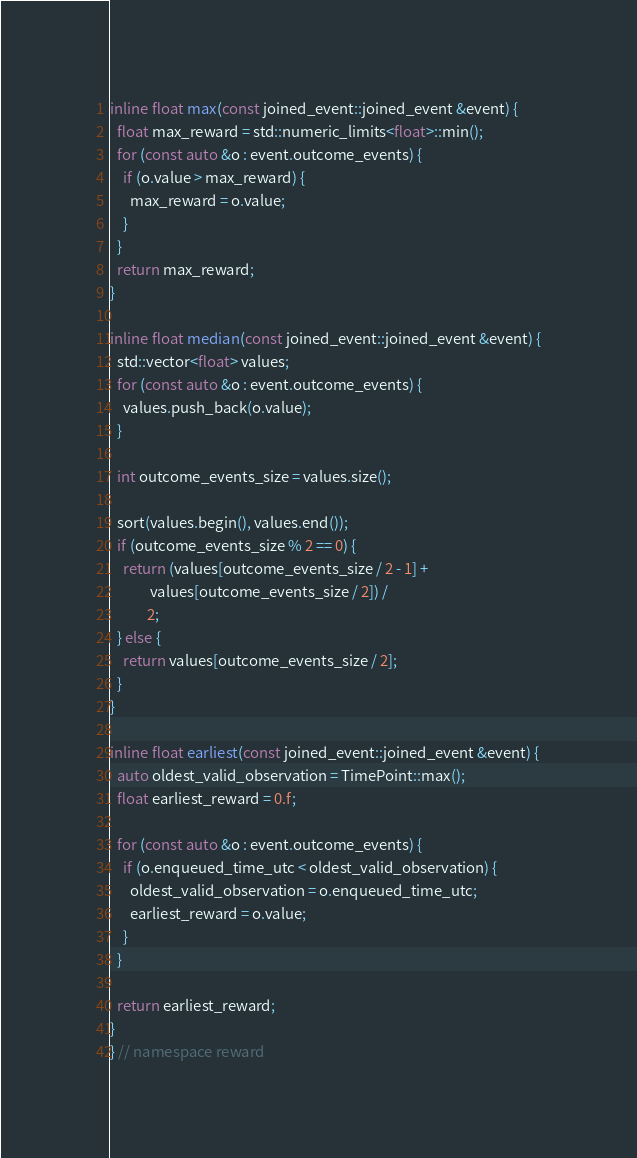<code> <loc_0><loc_0><loc_500><loc_500><_C_>inline float max(const joined_event::joined_event &event) {
  float max_reward = std::numeric_limits<float>::min();
  for (const auto &o : event.outcome_events) {
    if (o.value > max_reward) {
      max_reward = o.value;
    }
  }
  return max_reward;
}

inline float median(const joined_event::joined_event &event) {
  std::vector<float> values;
  for (const auto &o : event.outcome_events) {
    values.push_back(o.value);
  }

  int outcome_events_size = values.size();

  sort(values.begin(), values.end());
  if (outcome_events_size % 2 == 0) {
    return (values[outcome_events_size / 2 - 1] +
            values[outcome_events_size / 2]) /
           2;
  } else {
    return values[outcome_events_size / 2];
  }
}

inline float earliest(const joined_event::joined_event &event) {
  auto oldest_valid_observation = TimePoint::max();
  float earliest_reward = 0.f;

  for (const auto &o : event.outcome_events) {
    if (o.enqueued_time_utc < oldest_valid_observation) {
      oldest_valid_observation = o.enqueued_time_utc;
      earliest_reward = o.value;
    }
  }

  return earliest_reward;
}
} // namespace reward
</code> 